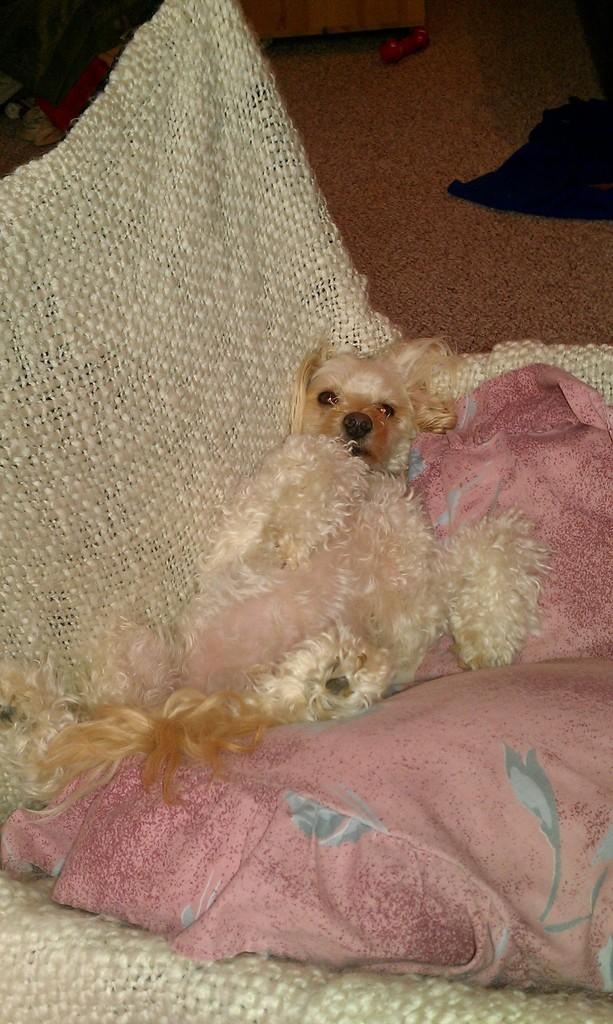What type of animal is present in the image? There is a dog in the image. Where is the dog located? The dog is lying on a couch. Can you describe any other objects or features in the background of the image? There is a black color thing on the top right of the floor in the background. What invention is the dog using to communicate with the audience in the image? There is no invention present in the image, and the dog is not communicating with the audience. 